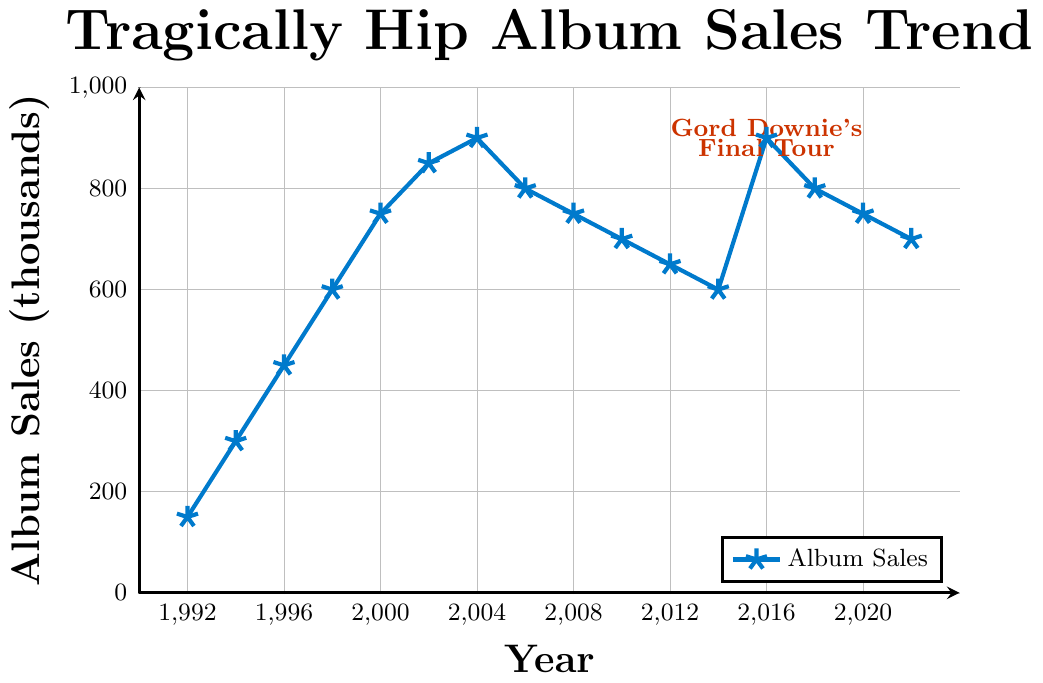What is the overall trend of Tragically Hip album sales from 1992 to 2022? Looking at the line chart, there is a clear increasing trend in album sales from 1992 to 2004, reaching a peak in 2004. After 2004, there’s a gradual decline in sales until 2016, where there's a temporary spike, followed by another decline towards 2022.
Answer: Increasing until 2004, then decreasing with a spike in 2016 How much did album sales increase from 1992 to 2002? Album sales in 1992 were 150,000 and increased to 850,000 by 2002. The increase can be calculated as 850,000 - 150,000 = 700,000.
Answer: 700,000 Which year had the highest album sales and what was the value? By examining the plot, 2004 had the highest album sales at 900,000.
Answer: 2004, 900,000 What is the album sales difference between 2004 and 2014? Album sales in 2004 were 900,000 and in 2014 they were 600,000. The difference is 900,000 - 600,000 = 300,000.
Answer: 300,000 How do the album sales in 2016 compare to those in 2006? Album sales in 2016 were 900,000, whereas in 2006 they were 800,000. Therefore, sales increased by 100,000 in 2016 compared to 2006.
Answer: 100,000 more in 2016 What was the average album sales over the period from 1992 to 2002? Summing the values from 1992, 1994, 1996, 1998, 2000, and 2002, we get 150 + 300 + 450 + 600 + 750 + 850 = 3100. The average sales over these years is 3100 / 6 = 516.67 thousand.
Answer: 516.67 thousand What major event is marked in the year 2016 on the plot? The plot marks "Gord Downie's Final Tour" in the year 2016, indicated by red text.
Answer: Gord Downie's Final Tour Which color is used to represent album sales on the plot? The color used to represent album sales on the plot is blue.
Answer: Blue How did album sales change from 2002 to 2012? From 2002 to 2012, album sales decreased from 850,000 to 650,000. The change in sales is 850,000 - 650,000 = 200,000.
Answer: Decreased by 200,000 Which years experienced a decline in album sales from the previous data point? Years that experienced a decline from the previous point are 2006, 2008, 2010, 2012, 2014, 2018, and 2022.
Answer: 2006, 2008, 2010, 2012, 2014, 2018, 2022 